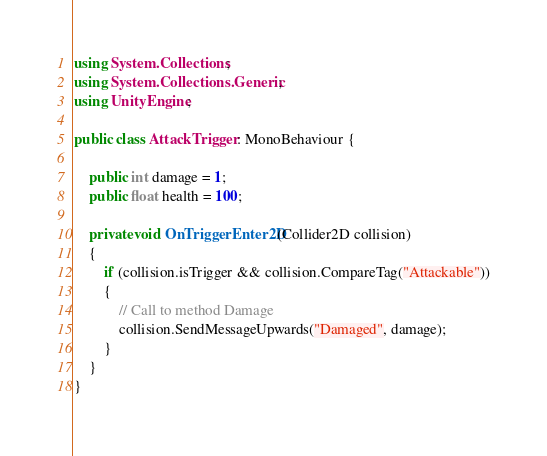<code> <loc_0><loc_0><loc_500><loc_500><_C#_>using System.Collections;
using System.Collections.Generic;
using UnityEngine;

public class AttackTrigger : MonoBehaviour {

    public int damage = 1;
    public float health = 100;

    private void OnTriggerEnter2D(Collider2D collision)
    {
        if (collision.isTrigger && collision.CompareTag("Attackable"))
        {
            // Call to method Damage
            collision.SendMessageUpwards("Damaged", damage);
        }
    }
}
</code> 